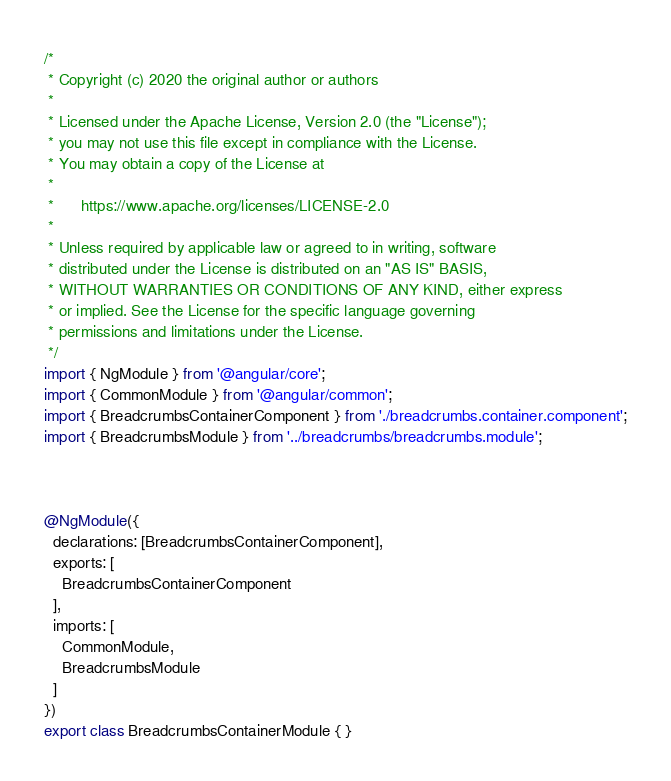<code> <loc_0><loc_0><loc_500><loc_500><_TypeScript_>/*
 * Copyright (c) 2020 the original author or authors
 *
 * Licensed under the Apache License, Version 2.0 (the "License");
 * you may not use this file except in compliance with the License.
 * You may obtain a copy of the License at
 *
 *      https://www.apache.org/licenses/LICENSE-2.0
 *
 * Unless required by applicable law or agreed to in writing, software
 * distributed under the License is distributed on an "AS IS" BASIS,
 * WITHOUT WARRANTIES OR CONDITIONS OF ANY KIND, either express
 * or implied. See the License for the specific language governing
 * permissions and limitations under the License.
 */
import { NgModule } from '@angular/core';
import { CommonModule } from '@angular/common';
import { BreadcrumbsContainerComponent } from './breadcrumbs.container.component';
import { BreadcrumbsModule } from '../breadcrumbs/breadcrumbs.module';



@NgModule({
  declarations: [BreadcrumbsContainerComponent],
  exports: [
    BreadcrumbsContainerComponent
  ],
  imports: [
    CommonModule,
    BreadcrumbsModule
  ]
})
export class BreadcrumbsContainerModule { }
</code> 